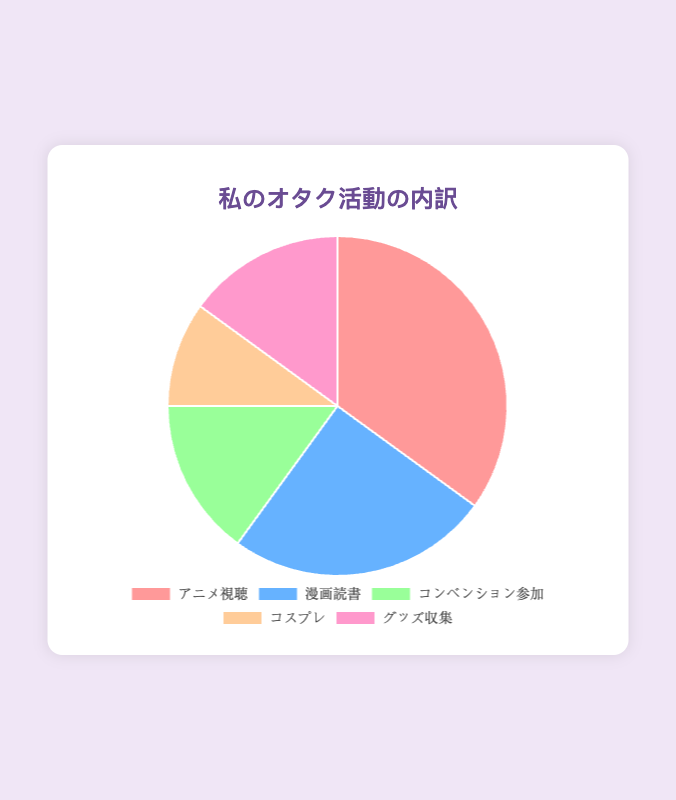What percentage of time is spent on activities other than watching anime? The pie chart shows that 35% of the time is spent watching anime. To find the percentage of time spent on other activities, subtract 35% from 100%. 100% - 35% = 65%
Answer: 65% Which activity has the least percentage of time spent? The pie chart indicates the percentages: Watching Anime (35%), Reading Manga (25%), Attending Conventions (15%), Cosplaying (10%), Collecting Merchandise (15%). The activity with the smallest percentage is Cosplaying with 10%
Answer: Cosplaying How much more time is spent reading manga compared to cosplaying? The percentage of time spent reading manga is 25%, and cosplaying is 10%. Subtract the cosplaying percentage from the manga percentage. 25% - 10% = 15%
Answer: 15% Which two activities have an equal percentage of time spent? According to the pie chart, Attending Conventions and Collecting Merchandise each take up 15% of the time spent on otaku activities
Answer: Attending Conventions and Collecting Merchandise What is the average percentage of time spent on attending conventions and cosplaying? The percentages for attending conventions and cosplaying are 15% and 10% respectively. To find the average, add the two percentages and divide by 2. (15% + 10%) / 2 = 12.5%
Answer: 12.5% Which activity has the largest slice of the pie, and what percentage does it represent? The activity with the largest slice is Watching Anime, which represents 35% of the total pie
Answer: Watching Anime, 35% If you were to combine the time spent on attending conventions and collecting merchandise, what total percentage would they represent? Both activities represent 15% each. Adding these gives 15% + 15% = 30%
Answer: 30% Which activities constitute exactly half of the time spent on otaku activities combined? Watching Anime takes up 35%, and Reading Manga takes up 25%. Adding these together gives 35% + 25% = 60%, which is not equal to 50%. The combination of Attending Conventions (15%), Cosplaying (10%), and Collecting Merchandise (15%) is 15% + 10% + 15% = 40%, also not equal to 50%. Therefore, no activities combine to exactly 50%
Answer: None 